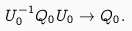<formula> <loc_0><loc_0><loc_500><loc_500>U _ { 0 } ^ { - 1 } Q _ { 0 } U _ { 0 } \rightarrow Q _ { 0 } .</formula> 